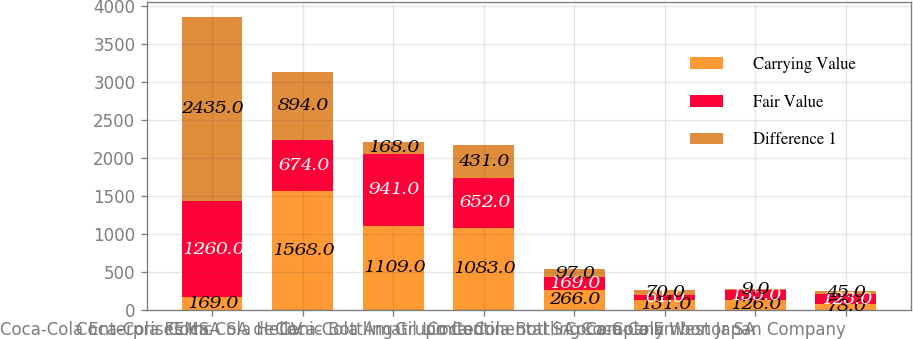Convert chart to OTSL. <chart><loc_0><loc_0><loc_500><loc_500><stacked_bar_chart><ecel><fcel>Coca-Cola Enterprises Inc<fcel>Coca-Cola FEMSA SA de CV<fcel>Coca-Cola Hellenic Bottling<fcel>Coca-Cola Amatil Limited<fcel>Grupo Continental SA<fcel>Coca-Cola Bottling Company<fcel>Coca-Cola Embonor SA<fcel>Coca-Cola West Japan Company<nl><fcel>Carrying Value<fcel>169<fcel>1568<fcel>1109<fcel>1083<fcel>266<fcel>131<fcel>126<fcel>78<nl><fcel>Fair Value<fcel>1260<fcel>674<fcel>941<fcel>652<fcel>169<fcel>61<fcel>135<fcel>123<nl><fcel>Difference 1<fcel>2435<fcel>894<fcel>168<fcel>431<fcel>97<fcel>70<fcel>9<fcel>45<nl></chart> 